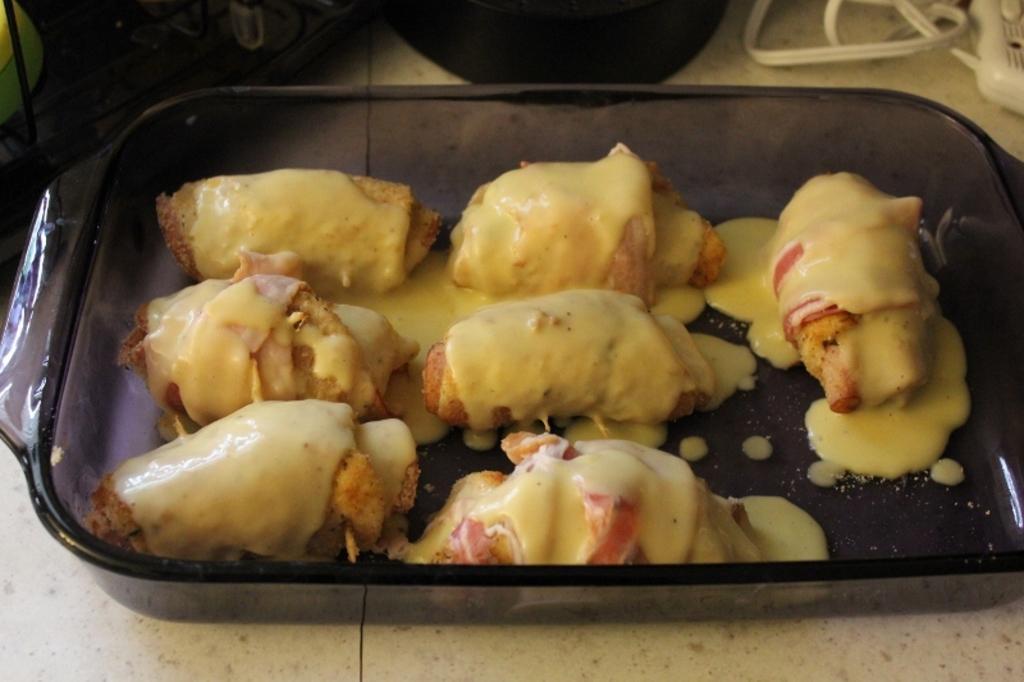In one or two sentences, can you explain what this image depicts? In this image we can see a serving tray in which food is topped with some sauce. 